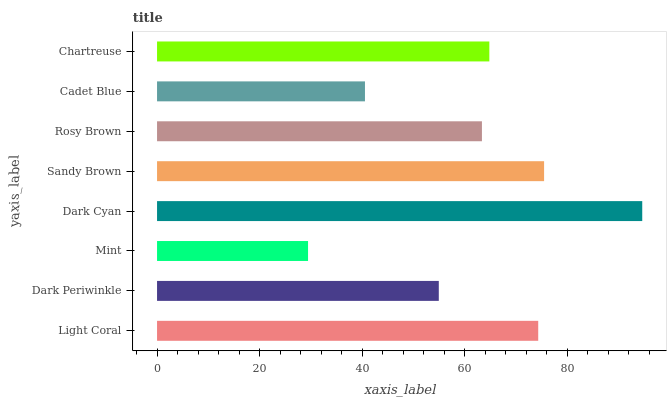Is Mint the minimum?
Answer yes or no. Yes. Is Dark Cyan the maximum?
Answer yes or no. Yes. Is Dark Periwinkle the minimum?
Answer yes or no. No. Is Dark Periwinkle the maximum?
Answer yes or no. No. Is Light Coral greater than Dark Periwinkle?
Answer yes or no. Yes. Is Dark Periwinkle less than Light Coral?
Answer yes or no. Yes. Is Dark Periwinkle greater than Light Coral?
Answer yes or no. No. Is Light Coral less than Dark Periwinkle?
Answer yes or no. No. Is Chartreuse the high median?
Answer yes or no. Yes. Is Rosy Brown the low median?
Answer yes or no. Yes. Is Mint the high median?
Answer yes or no. No. Is Light Coral the low median?
Answer yes or no. No. 